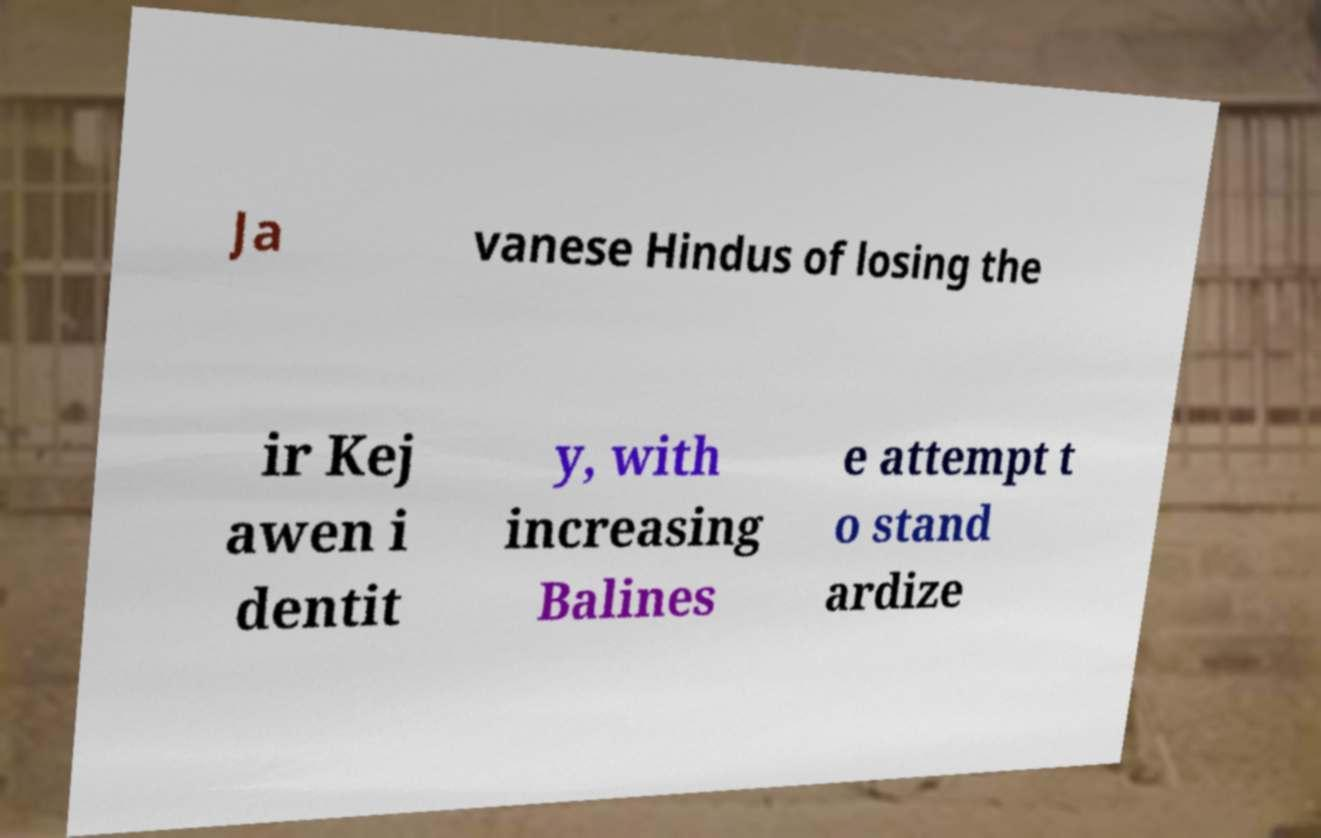There's text embedded in this image that I need extracted. Can you transcribe it verbatim? Ja vanese Hindus of losing the ir Kej awen i dentit y, with increasing Balines e attempt t o stand ardize 